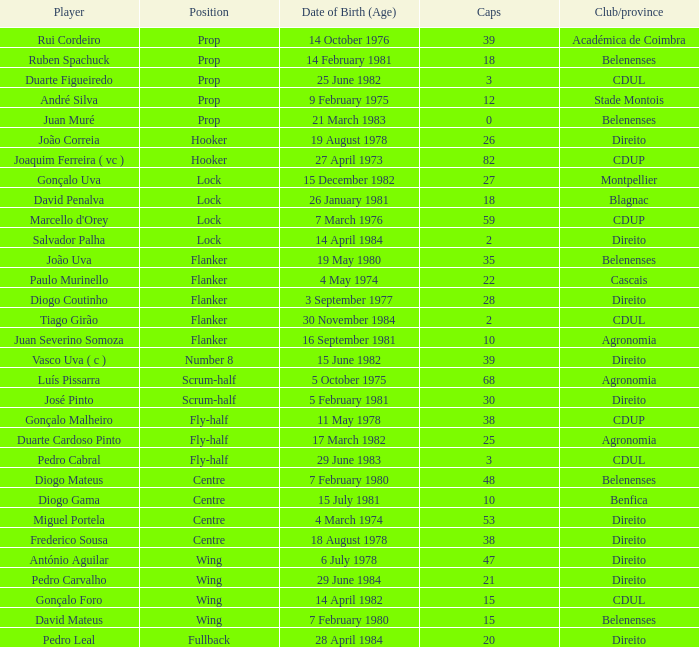What is the count of caps with a date of birth (age) on july 15, 1981? 1.0. 